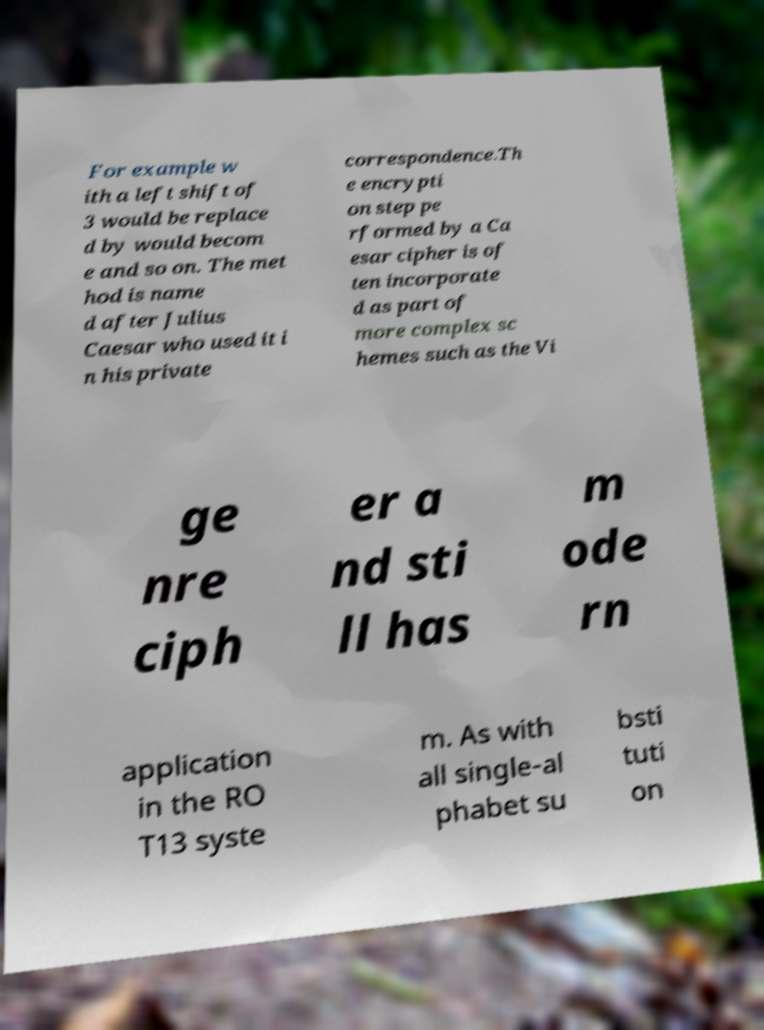I need the written content from this picture converted into text. Can you do that? For example w ith a left shift of 3 would be replace d by would becom e and so on. The met hod is name d after Julius Caesar who used it i n his private correspondence.Th e encrypti on step pe rformed by a Ca esar cipher is of ten incorporate d as part of more complex sc hemes such as the Vi ge nre ciph er a nd sti ll has m ode rn application in the RO T13 syste m. As with all single-al phabet su bsti tuti on 